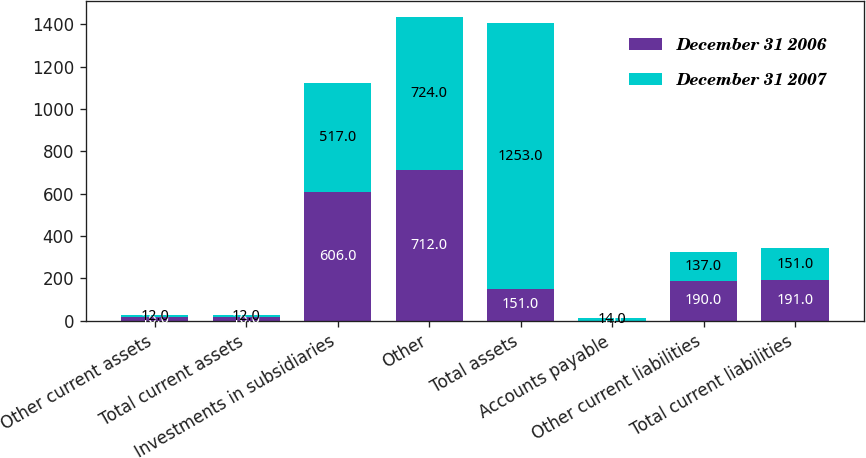<chart> <loc_0><loc_0><loc_500><loc_500><stacked_bar_chart><ecel><fcel>Other current assets<fcel>Total current assets<fcel>Investments in subsidiaries<fcel>Other<fcel>Total assets<fcel>Accounts payable<fcel>Other current liabilities<fcel>Total current liabilities<nl><fcel>December 31 2006<fcel>16<fcel>16<fcel>606<fcel>712<fcel>151<fcel>1<fcel>190<fcel>191<nl><fcel>December 31 2007<fcel>12<fcel>12<fcel>517<fcel>724<fcel>1253<fcel>14<fcel>137<fcel>151<nl></chart> 